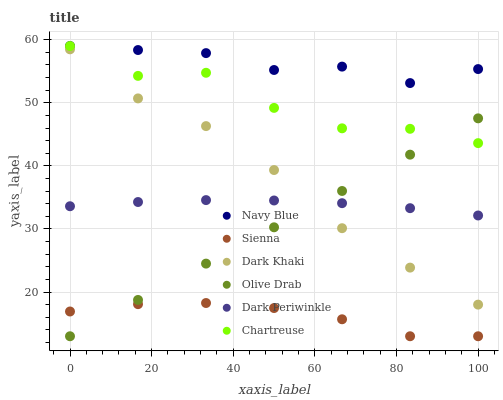Does Sienna have the minimum area under the curve?
Answer yes or no. Yes. Does Navy Blue have the maximum area under the curve?
Answer yes or no. Yes. Does Navy Blue have the minimum area under the curve?
Answer yes or no. No. Does Sienna have the maximum area under the curve?
Answer yes or no. No. Is Olive Drab the smoothest?
Answer yes or no. Yes. Is Chartreuse the roughest?
Answer yes or no. Yes. Is Navy Blue the smoothest?
Answer yes or no. No. Is Navy Blue the roughest?
Answer yes or no. No. Does Sienna have the lowest value?
Answer yes or no. Yes. Does Navy Blue have the lowest value?
Answer yes or no. No. Does Chartreuse have the highest value?
Answer yes or no. Yes. Does Sienna have the highest value?
Answer yes or no. No. Is Dark Periwinkle less than Chartreuse?
Answer yes or no. Yes. Is Navy Blue greater than Dark Periwinkle?
Answer yes or no. Yes. Does Navy Blue intersect Chartreuse?
Answer yes or no. Yes. Is Navy Blue less than Chartreuse?
Answer yes or no. No. Is Navy Blue greater than Chartreuse?
Answer yes or no. No. Does Dark Periwinkle intersect Chartreuse?
Answer yes or no. No. 